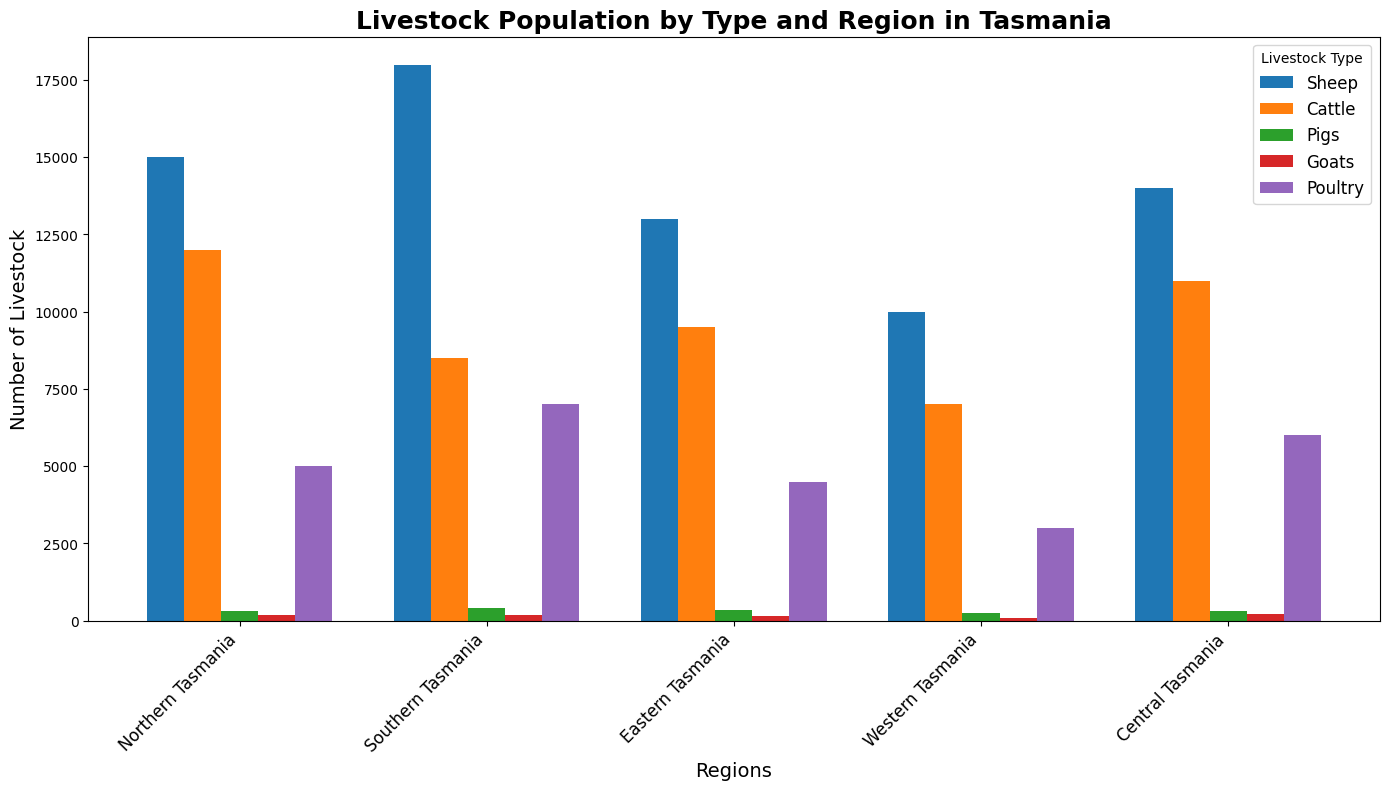Which region has the highest sheep population? Compare the heights of the bars representing the sheep population across all regions. The tallest bar is the one representing Southern Tasmania.
Answer: Southern Tasmania What is the total number of cattle in Northern and Eastern Tasmania combined? Add the number of cattle in Northern Tasmania (12000) to the number of cattle in Eastern Tasmania (9500). 12000 + 9500 = 21500.
Answer: 21500 How many more poultry are there in Southern Tasmania compared to Western Tasmania? Subtract the number of poultry in Western Tasmania (3000) from the number of poultry in Southern Tasmania (7000). 7000 - 3000 = 4000.
Answer: 4000 Which livestock type is least populous in Central Tasmania? Look at Central Tasmania's heights of the bars for each livestock type and find the shortest bar, which represents goats (210).
Answer: Goats What is the average number of pigs across all regions? Sum the number of pigs in all regions and divide by the number of regions: (300 + 400 + 350 + 250 + 320) / 5 = 1620 / 5 = 324.
Answer: 324 Which region has the smallest total livestock population? Sum the livestock populations (sheep + cattle + pigs + goats + poultry) for each region and find the smallest sum: {Northern Tasmania: 15000 + 12000 + 300 + 200 + 5000 = 32500, Southern Tasmania: 18000 + 8500 + 400 + 180 + 7000 = 34180, Eastern Tasmania: 13000 + 9500 + 350 + 160 + 4500 = 27650, Western Tasmania: 10000 + 7000 + 250 + 100 + 3000 = 20350, Central Tasmania: 14000 + 11000 + 320 + 210 + 6000 = 31540}. Western Tasmania has the smallest total population.
Answer: Western Tasmania Which region has the most diverse livestock population, considering when population counts among livestock types are more evenly spread out? Evaluate the differences between the populations of different livestock types within each region. If the livestock populations are more closely numbered within a region, it suggests more diversity. Western Tasmania displays a more balanced spread between the livestock types.
Answer: Western Tasmania 